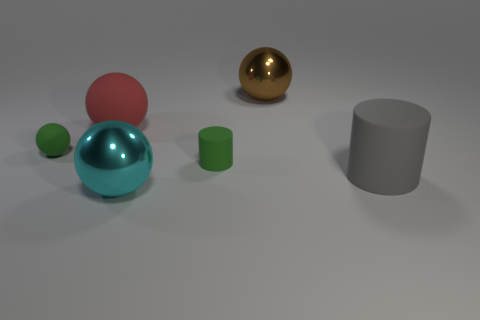How many objects are there in the image, and can you describe their shapes? There are five distinct objects in the image. Starting from the left, there is a blue shiny sphere, followed by a pink large sphere and a small green sphere. On the right, there is a metallic gold-colored sphere and a large gray cylindrical object. 